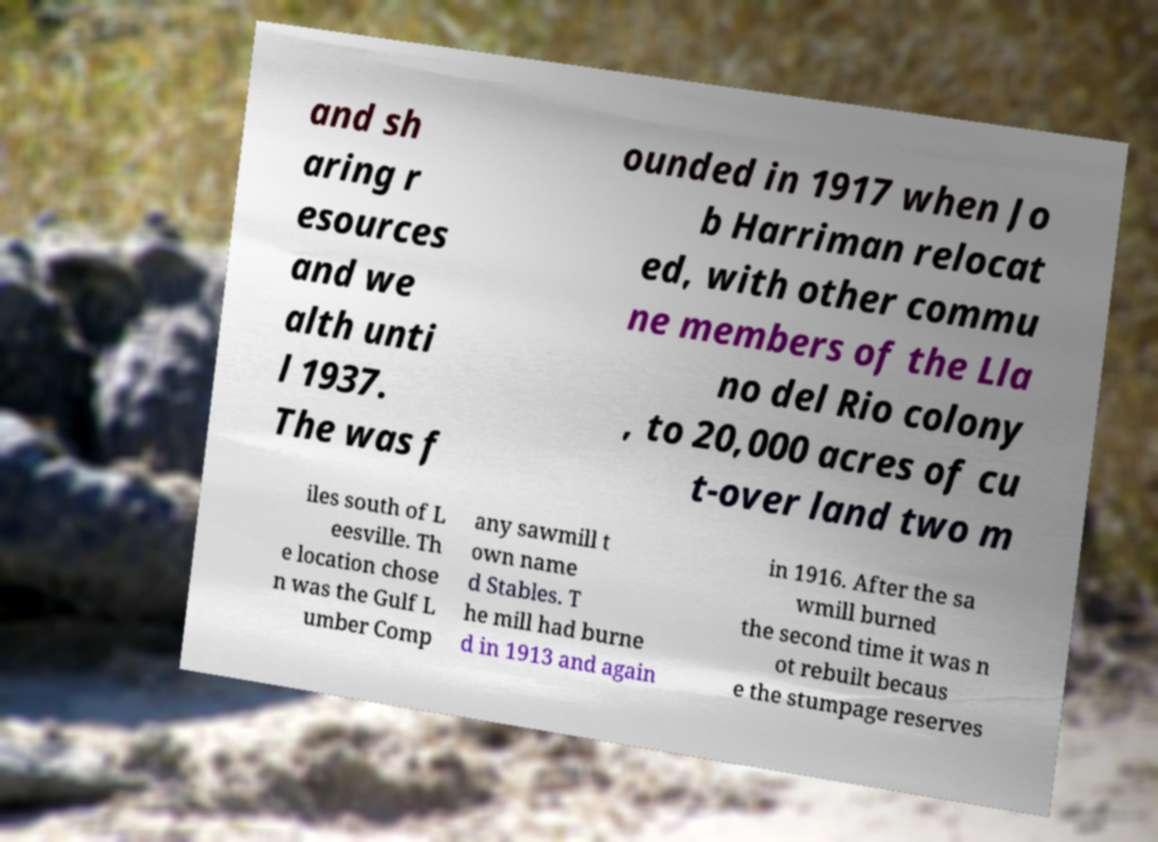Please read and relay the text visible in this image. What does it say? and sh aring r esources and we alth unti l 1937. The was f ounded in 1917 when Jo b Harriman relocat ed, with other commu ne members of the Lla no del Rio colony , to 20,000 acres of cu t-over land two m iles south of L eesville. Th e location chose n was the Gulf L umber Comp any sawmill t own name d Stables. T he mill had burne d in 1913 and again in 1916. After the sa wmill burned the second time it was n ot rebuilt becaus e the stumpage reserves 